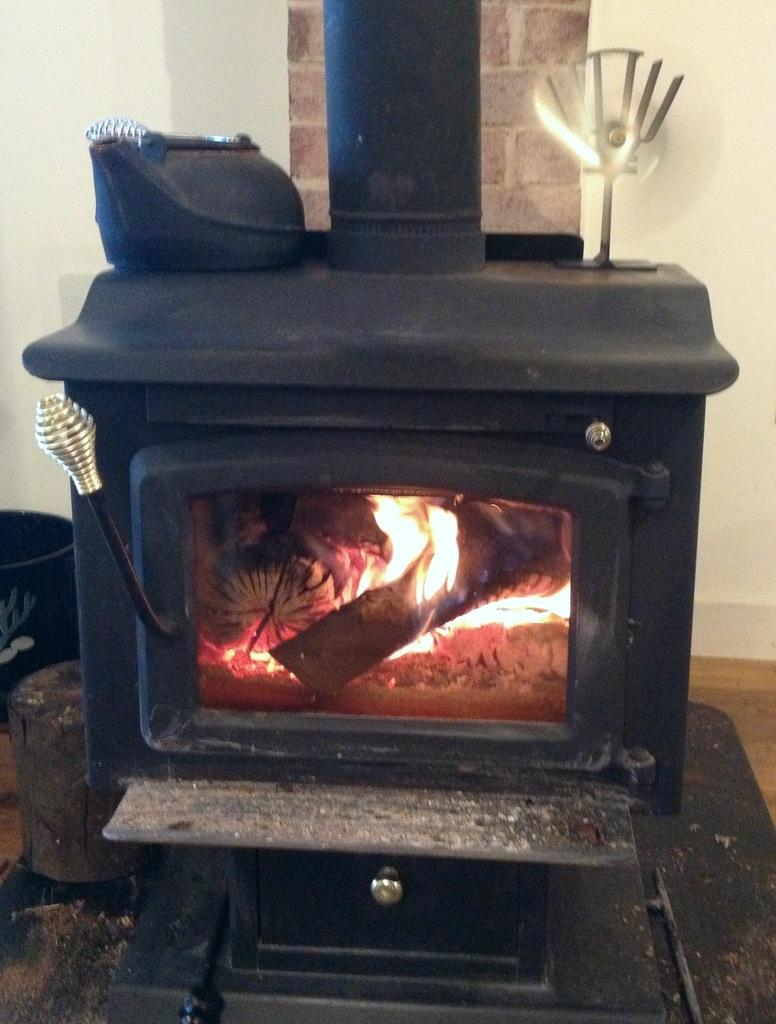What type of stove is in the image? There is a black color wood burning stove in the image. What is happening with the stove in the image? Wood is burning in the stove. What is visible behind the stove? There is a wall behind the stove. Where is the wood pile located in the image? The wood pile is on the left side of the image. Can you see any mountains in the image? There are no mountains visible in the image. Is there a squirrel sitting on the wood pile in the image? There is no squirrel present in the image. 